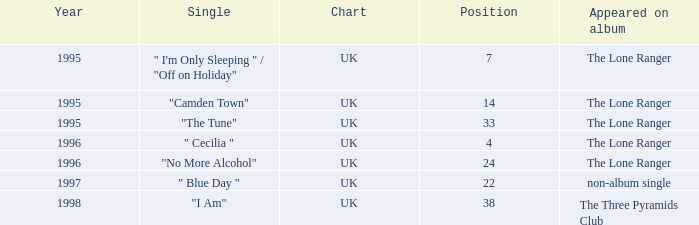Post-1996, what is the average location? 30.0. 